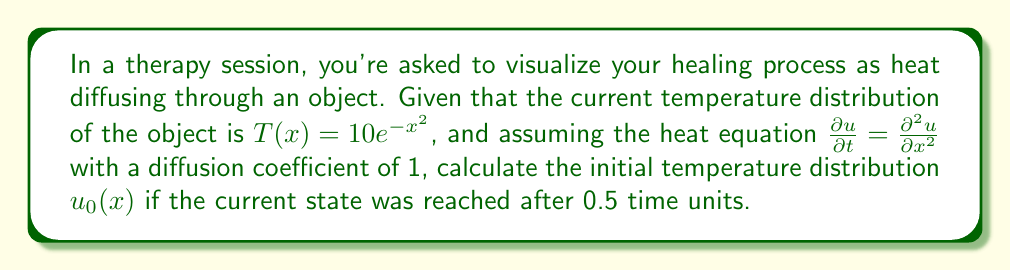Show me your answer to this math problem. To solve this inverse problem, we'll use the relationship between the initial and current temperature distributions in the context of the heat equation:

1) The solution to the heat equation with initial condition $u_0(x)$ is given by:

   $u(x,t) = \frac{1}{\sqrt{4\pi t}} \int_{-\infty}^{\infty} u_0(y) e^{-\frac{(x-y)^2}{4t}} dy$

2) We're given that $T(x) = u(x,0.5) = 10e^{-x^2}$

3) To find $u_0(x)$, we need to "reverse" the heat equation. This can be done by applying the Fourier transform to both sides:

   $\hat{u}(k,t) = \hat{u}_0(k) e^{-k^2t}$

4) The Fourier transform of $T(x) = 10e^{-x^2}$ is:

   $\hat{T}(k) = 10\sqrt{\pi} e^{-k^2/4}$

5) Therefore:

   $10\sqrt{\pi} e^{-k^2/4} = \hat{u}_0(k) e^{-k^2(0.5)}$

6) Solving for $\hat{u}_0(k)$:

   $\hat{u}_0(k) = 10\sqrt{\pi} e^{-k^2/4} e^{k^2(0.5)} = 10\sqrt{\pi} e^{k^2/4}$

7) Taking the inverse Fourier transform:

   $u_0(x) = \frac{10}{\sqrt{2}} e^{2x^2}$

This represents the initial temperature distribution.
Answer: $u_0(x) = \frac{10}{\sqrt{2}} e^{2x^2}$ 